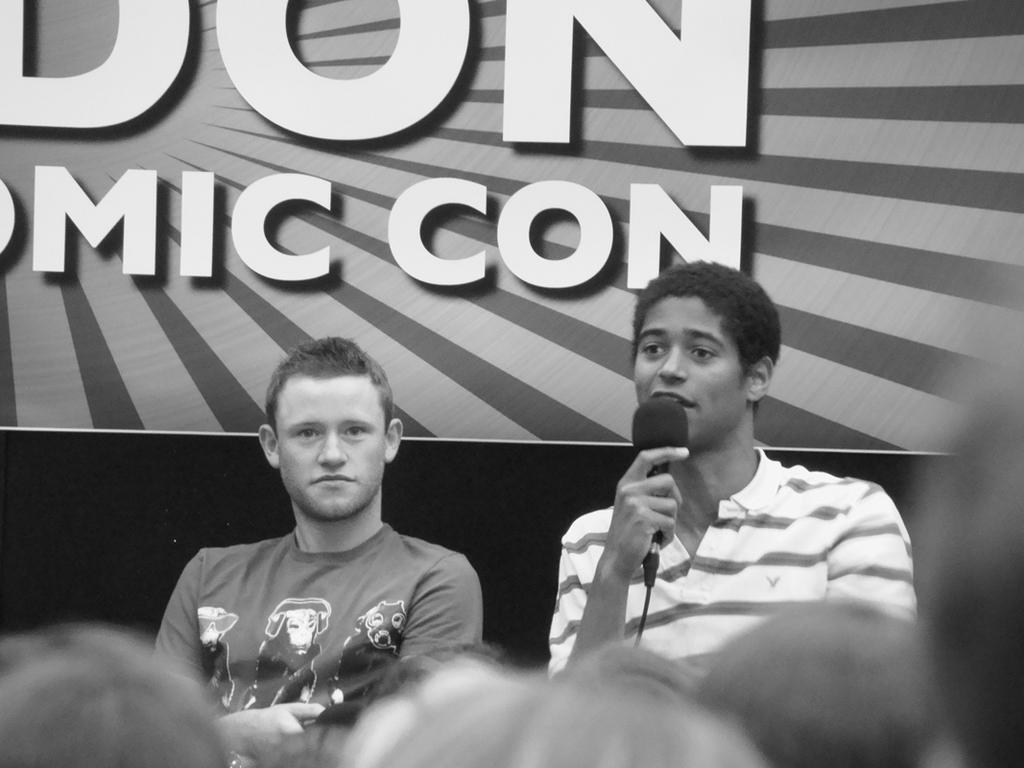Describe this image in one or two sentences. In this image I can see two men where one is holding a mic. 